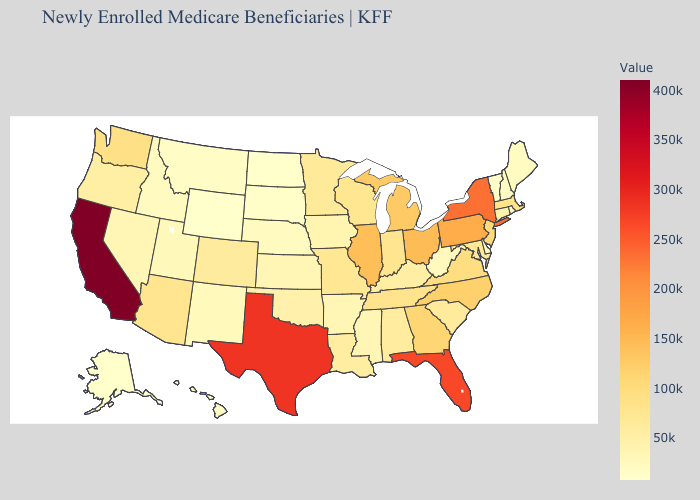Does South Carolina have the lowest value in the South?
Short answer required. No. Which states have the highest value in the USA?
Quick response, please. California. Does Texas have the highest value in the South?
Write a very short answer. Yes. Does Virginia have the lowest value in the South?
Short answer required. No. Which states have the highest value in the USA?
Short answer required. California. Among the states that border California , which have the highest value?
Quick response, please. Arizona. Does the map have missing data?
Answer briefly. No. Does the map have missing data?
Short answer required. No. 